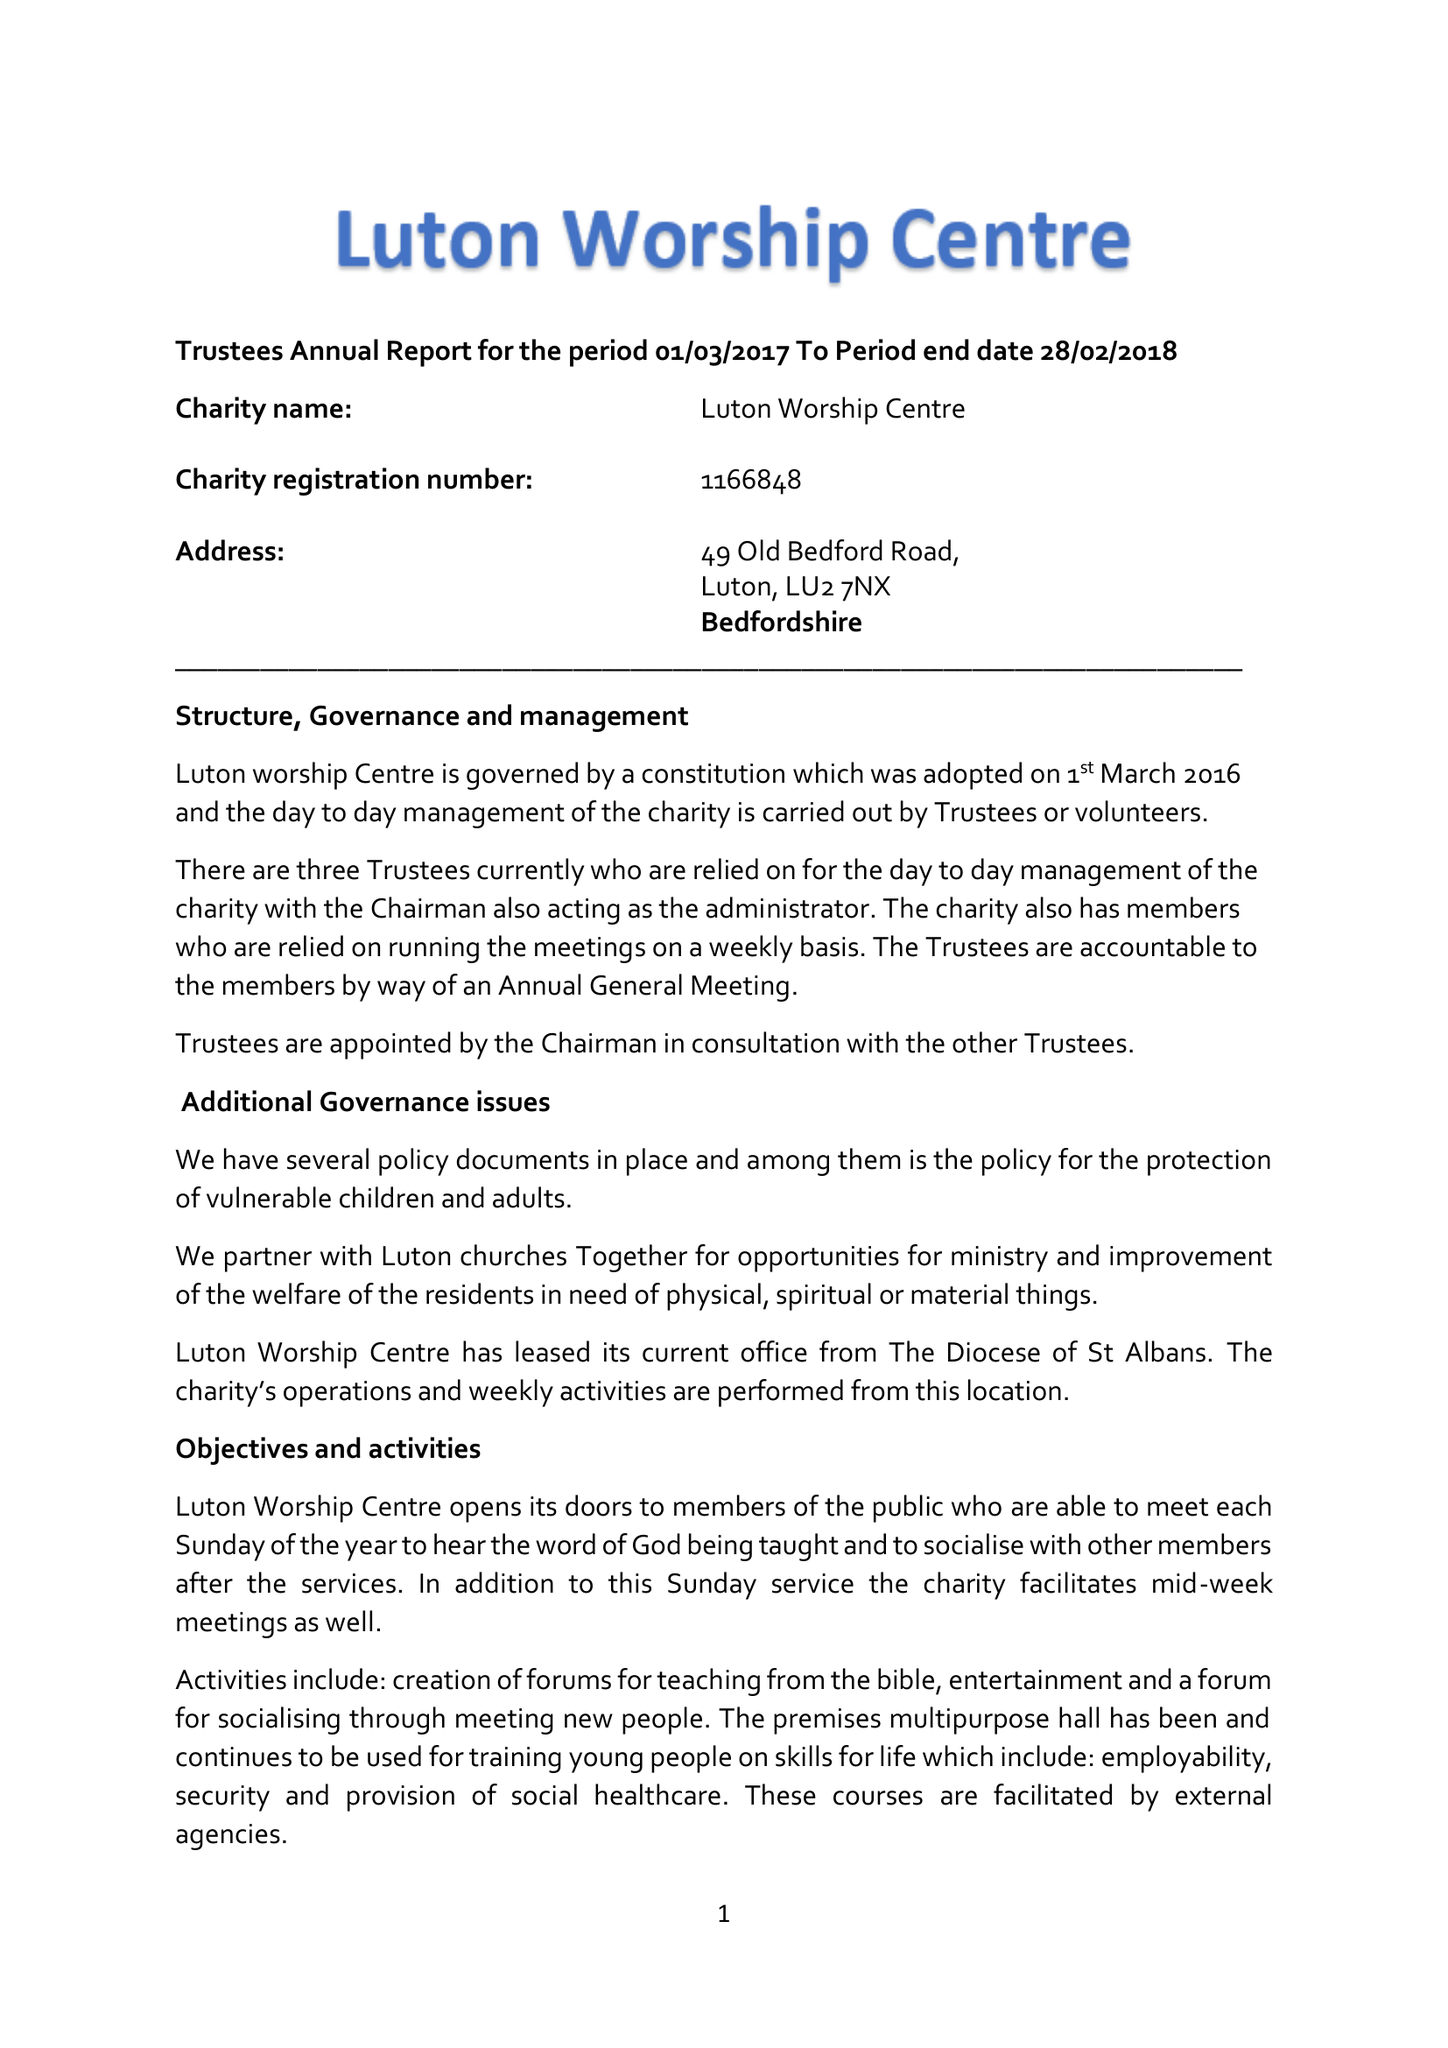What is the value for the report_date?
Answer the question using a single word or phrase. 2018-02-28 